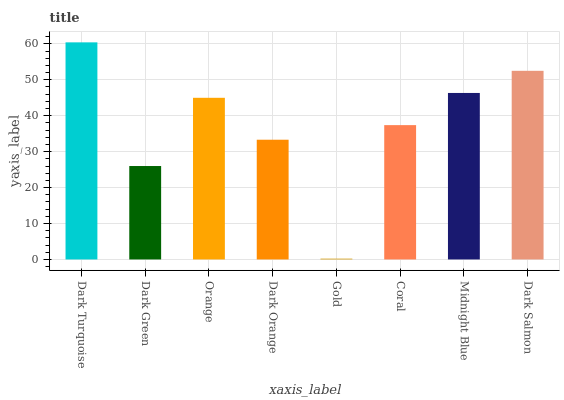Is Dark Green the minimum?
Answer yes or no. No. Is Dark Green the maximum?
Answer yes or no. No. Is Dark Turquoise greater than Dark Green?
Answer yes or no. Yes. Is Dark Green less than Dark Turquoise?
Answer yes or no. Yes. Is Dark Green greater than Dark Turquoise?
Answer yes or no. No. Is Dark Turquoise less than Dark Green?
Answer yes or no. No. Is Orange the high median?
Answer yes or no. Yes. Is Coral the low median?
Answer yes or no. Yes. Is Dark Green the high median?
Answer yes or no. No. Is Dark Salmon the low median?
Answer yes or no. No. 